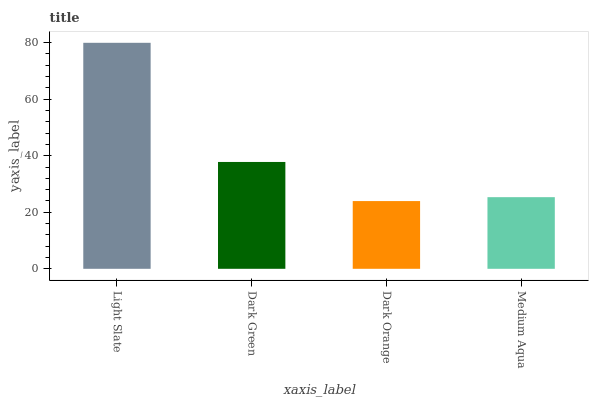Is Dark Orange the minimum?
Answer yes or no. Yes. Is Light Slate the maximum?
Answer yes or no. Yes. Is Dark Green the minimum?
Answer yes or no. No. Is Dark Green the maximum?
Answer yes or no. No. Is Light Slate greater than Dark Green?
Answer yes or no. Yes. Is Dark Green less than Light Slate?
Answer yes or no. Yes. Is Dark Green greater than Light Slate?
Answer yes or no. No. Is Light Slate less than Dark Green?
Answer yes or no. No. Is Dark Green the high median?
Answer yes or no. Yes. Is Medium Aqua the low median?
Answer yes or no. Yes. Is Light Slate the high median?
Answer yes or no. No. Is Light Slate the low median?
Answer yes or no. No. 